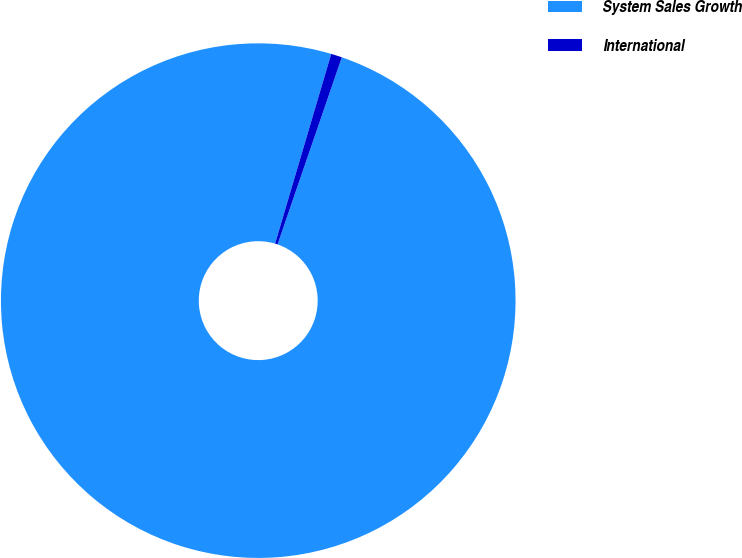Convert chart to OTSL. <chart><loc_0><loc_0><loc_500><loc_500><pie_chart><fcel>System Sales Growth<fcel>International<nl><fcel>99.31%<fcel>0.69%<nl></chart> 